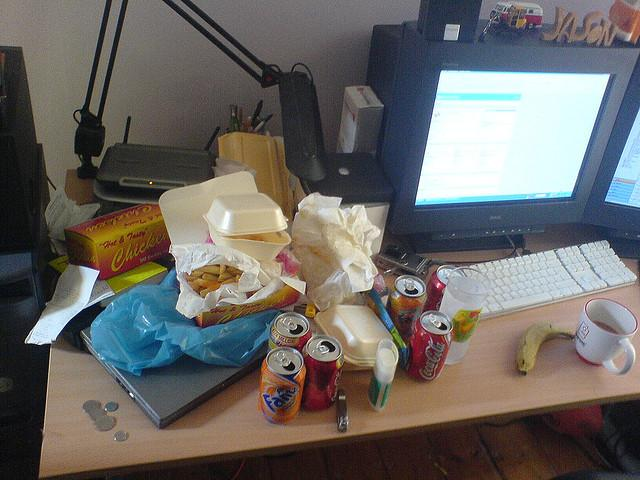Where is Coca-Cola's headquarters located?

Choices:
A) arizona
B) georgia
C) utah
D) maine georgia 